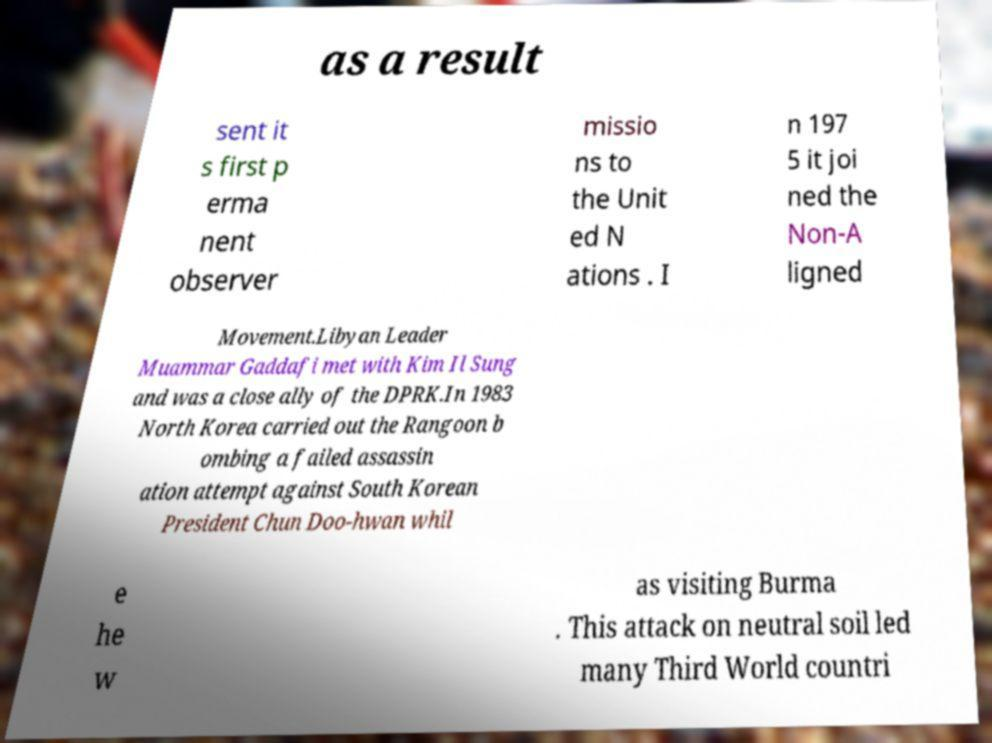Could you extract and type out the text from this image? as a result sent it s first p erma nent observer missio ns to the Unit ed N ations . I n 197 5 it joi ned the Non-A ligned Movement.Libyan Leader Muammar Gaddafi met with Kim Il Sung and was a close ally of the DPRK.In 1983 North Korea carried out the Rangoon b ombing a failed assassin ation attempt against South Korean President Chun Doo-hwan whil e he w as visiting Burma . This attack on neutral soil led many Third World countri 